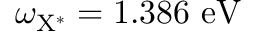<formula> <loc_0><loc_0><loc_500><loc_500>\omega _ { { X ^ { * } } } = 1 . 3 8 6 { e V }</formula> 